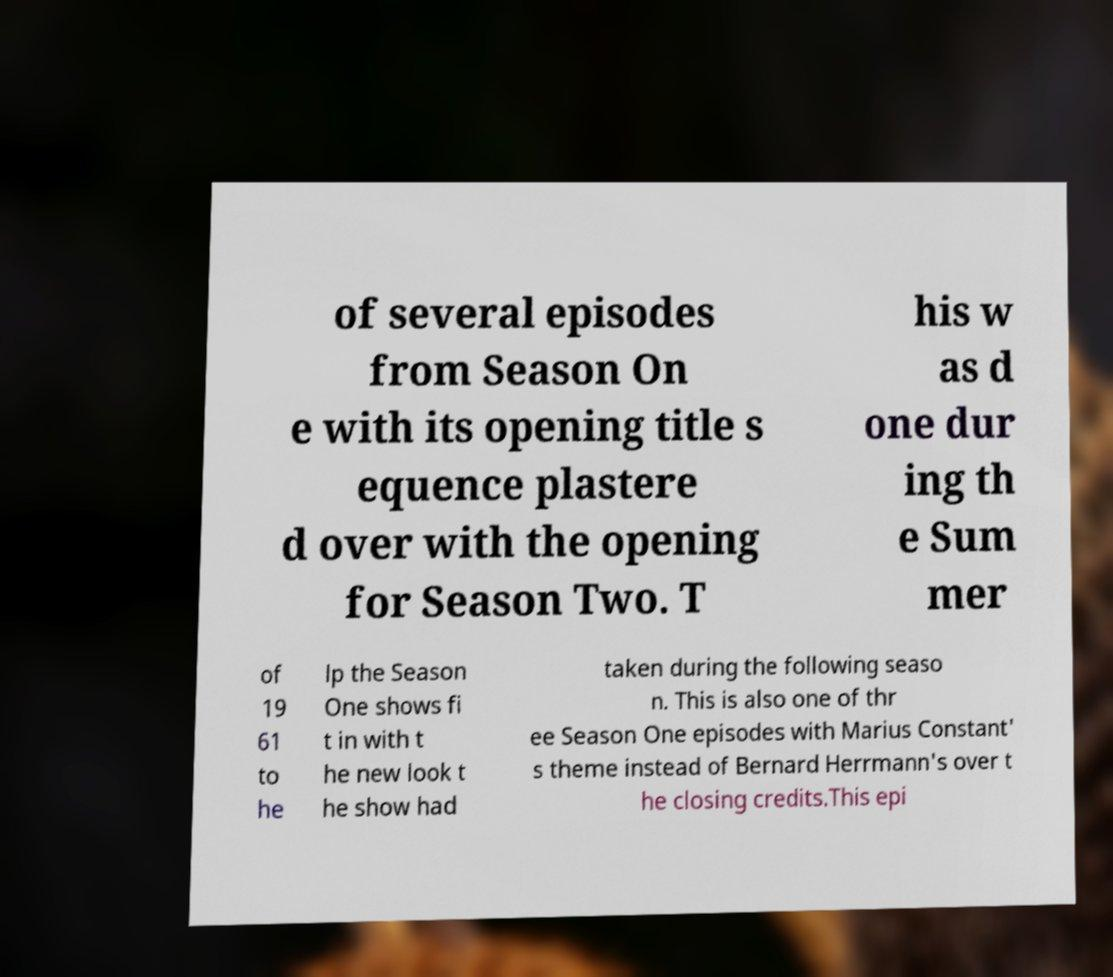I need the written content from this picture converted into text. Can you do that? of several episodes from Season On e with its opening title s equence plastere d over with the opening for Season Two. T his w as d one dur ing th e Sum mer of 19 61 to he lp the Season One shows fi t in with t he new look t he show had taken during the following seaso n. This is also one of thr ee Season One episodes with Marius Constant' s theme instead of Bernard Herrmann's over t he closing credits.This epi 